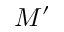Convert formula to latex. <formula><loc_0><loc_0><loc_500><loc_500>M ^ { \prime }</formula> 